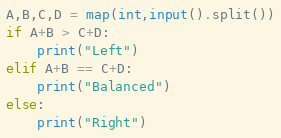<code> <loc_0><loc_0><loc_500><loc_500><_Python_>A,B,C,D = map(int,input().split())
if A+B > C+D:
    print("Left")
elif A+B == C+D:
    print("Balanced")
else:
    print("Right")</code> 